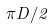<formula> <loc_0><loc_0><loc_500><loc_500>\pi D / 2</formula> 